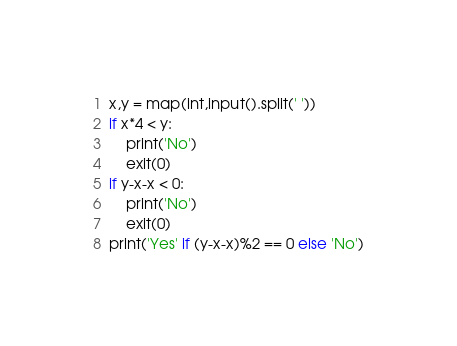<code> <loc_0><loc_0><loc_500><loc_500><_Python_>x,y = map(int,input().split(' '))
if x*4 < y:
    print('No')
    exit(0)
if y-x-x < 0:
    print('No')
    exit(0)
print('Yes' if (y-x-x)%2 == 0 else 'No')</code> 